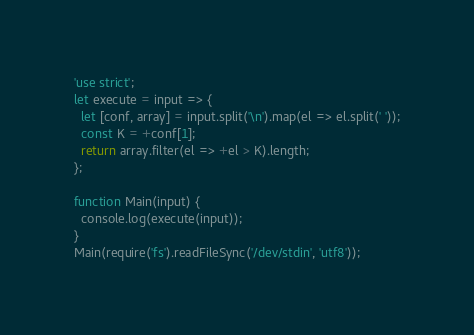<code> <loc_0><loc_0><loc_500><loc_500><_JavaScript_>'use strict';
let execute = input => {
  let [conf, array] = input.split('\n').map(el => el.split(' '));
  const K = +conf[1];
  return array.filter(el => +el > K).length;
};

function Main(input) {
  console.log(execute(input));
}
Main(require('fs').readFileSync('/dev/stdin', 'utf8'));</code> 